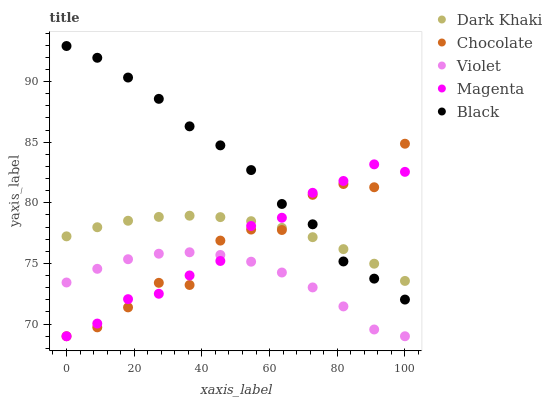Does Violet have the minimum area under the curve?
Answer yes or no. Yes. Does Black have the maximum area under the curve?
Answer yes or no. Yes. Does Magenta have the minimum area under the curve?
Answer yes or no. No. Does Magenta have the maximum area under the curve?
Answer yes or no. No. Is Dark Khaki the smoothest?
Answer yes or no. Yes. Is Chocolate the roughest?
Answer yes or no. Yes. Is Magenta the smoothest?
Answer yes or no. No. Is Magenta the roughest?
Answer yes or no. No. Does Magenta have the lowest value?
Answer yes or no. Yes. Does Black have the lowest value?
Answer yes or no. No. Does Black have the highest value?
Answer yes or no. Yes. Does Magenta have the highest value?
Answer yes or no. No. Is Violet less than Dark Khaki?
Answer yes or no. Yes. Is Dark Khaki greater than Violet?
Answer yes or no. Yes. Does Dark Khaki intersect Black?
Answer yes or no. Yes. Is Dark Khaki less than Black?
Answer yes or no. No. Is Dark Khaki greater than Black?
Answer yes or no. No. Does Violet intersect Dark Khaki?
Answer yes or no. No. 